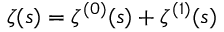Convert formula to latex. <formula><loc_0><loc_0><loc_500><loc_500>\zeta ( s ) = \zeta ^ { ( 0 ) } ( s ) + \zeta ^ { ( 1 ) } ( s )</formula> 